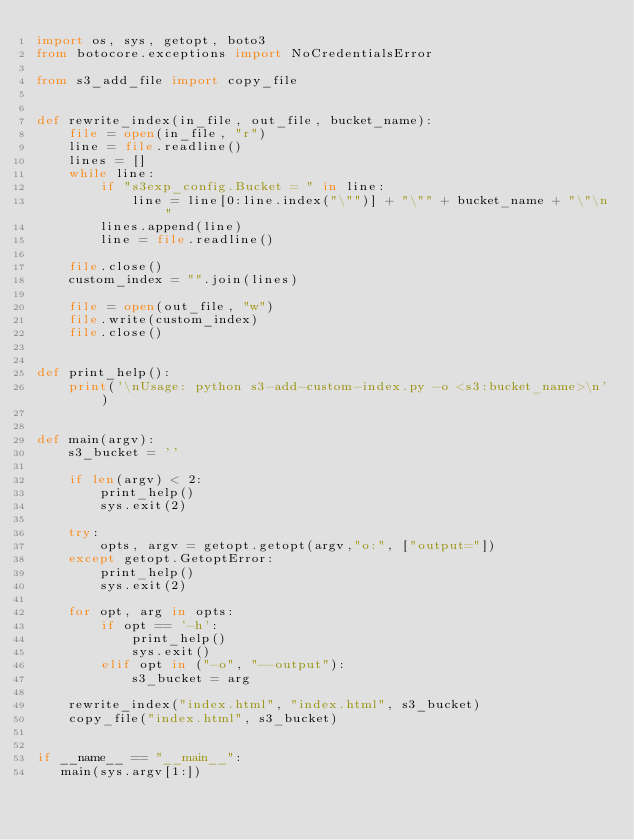Convert code to text. <code><loc_0><loc_0><loc_500><loc_500><_Python_>import os, sys, getopt, boto3
from botocore.exceptions import NoCredentialsError

from s3_add_file import copy_file


def rewrite_index(in_file, out_file, bucket_name):
    file = open(in_file, "r")
    line = file.readline()
    lines = []
    while line:
        if "s3exp_config.Bucket = " in line:
            line = line[0:line.index("\"")] + "\"" + bucket_name + "\"\n"
        lines.append(line)
        line = file.readline()

    file.close()    
    custom_index = "".join(lines)
    
    file = open(out_file, "w")
    file.write(custom_index)
    file.close()


def print_help():
    print('\nUsage: python s3-add-custom-index.py -o <s3:bucket_name>\n')


def main(argv):
    s3_bucket = ''

    if len(argv) < 2:
        print_help()
        sys.exit(2)

    try:
        opts, argv = getopt.getopt(argv,"o:", ["output="])
    except getopt.GetoptError:
        print_help()
        sys.exit(2)

    for opt, arg in opts:
        if opt == '-h':
            print_help()
            sys.exit()
        elif opt in ("-o", "--output"):
            s3_bucket = arg

    rewrite_index("index.html", "index.html", s3_bucket)
    copy_file("index.html", s3_bucket)
    

if __name__ == "__main__":
   main(sys.argv[1:])</code> 